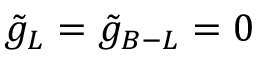<formula> <loc_0><loc_0><loc_500><loc_500>{ \tilde { g } _ { L } } = { \tilde { g } _ { B - L } } = 0</formula> 